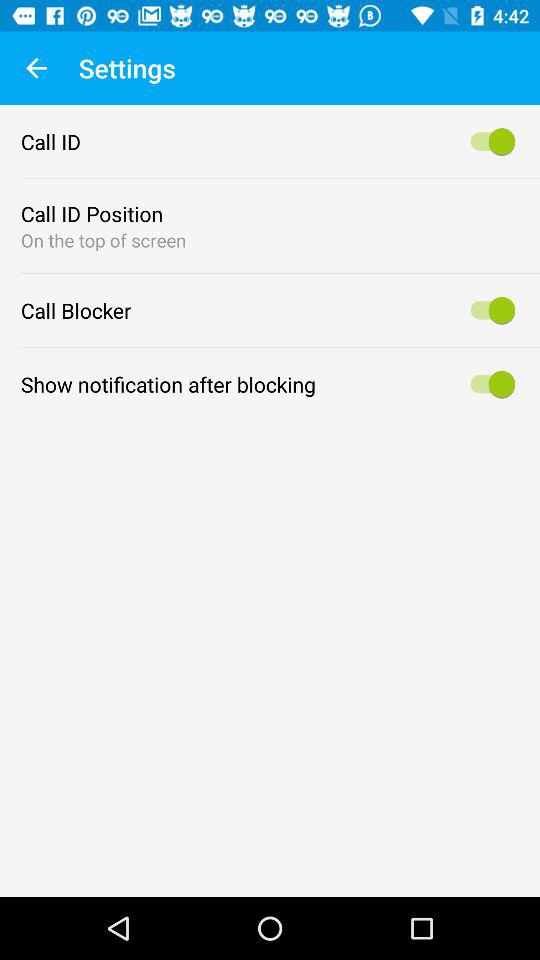What's the status of "Call Blocker"? The status is "on". 